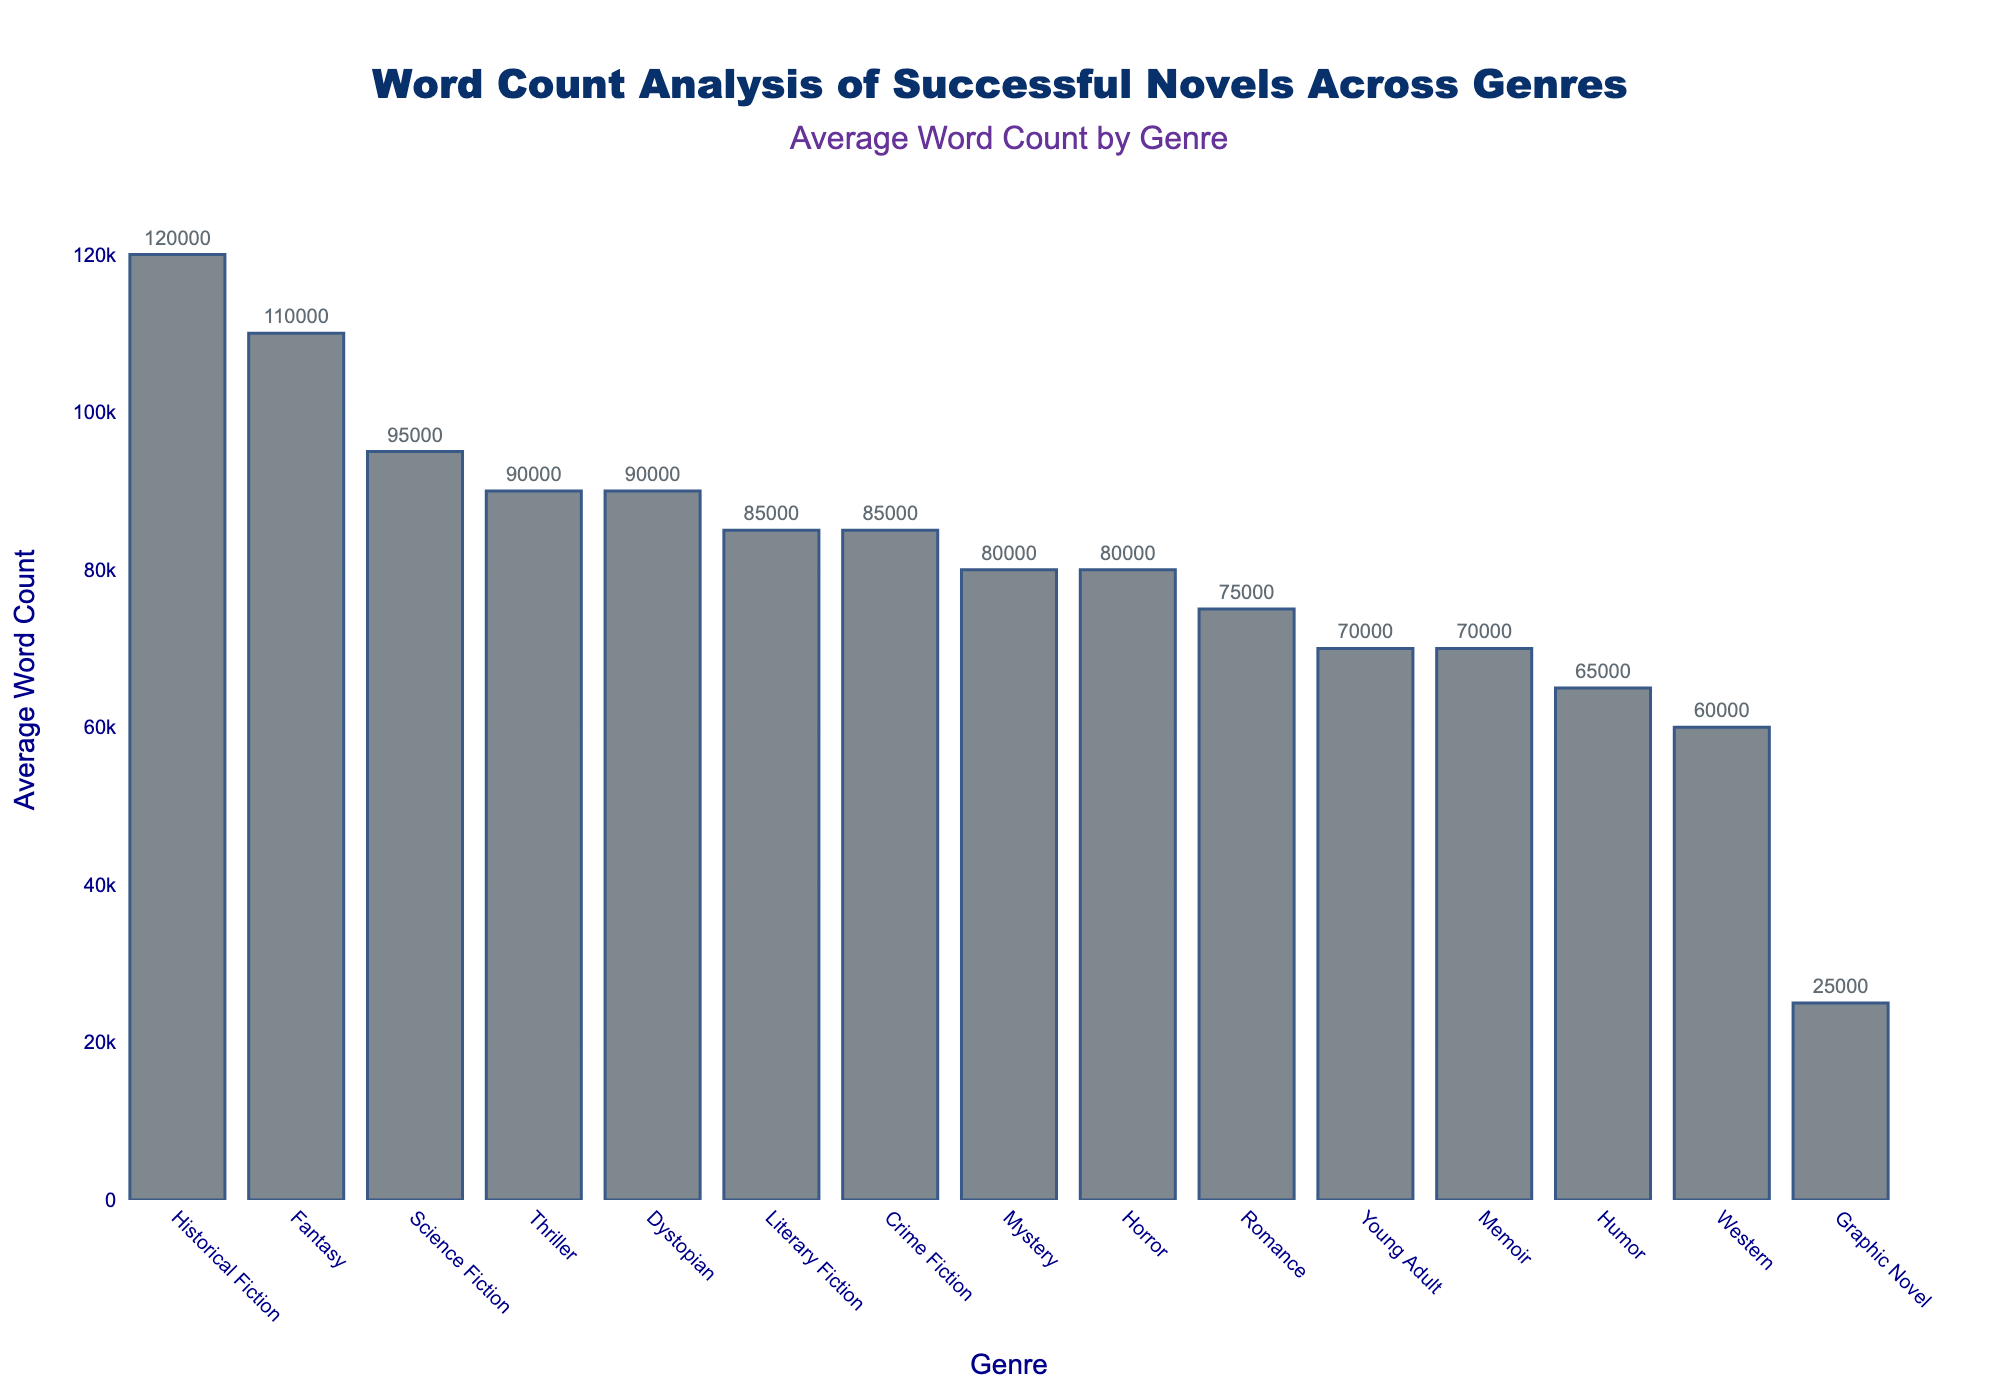Which genre has the highest average word count? By looking at the height of the bars, the highest bar corresponds to Historical Fiction.
Answer: Historical Fiction Which genre has the lowest average word count? The shortest bar corresponds to Graphic Novel.
Answer: Graphic Novel How does the average word count of Fantasy compare to Science Fiction? The bar for Fantasy is taller than the bar for Science Fiction, indicating that Fantasy has a higher average word count.
Answer: Fantasy is higher What is the difference in average word count between Historical Fiction and Romance? Historical Fiction has an average word count of 120,000, and Romance has 75,000. Subtracting these values gives 120,000 - 75,000.
Answer: 45,000 Is the average word count for Dystopian novels closer to Science Fiction or Thriller? The average word counts are: Dystopian (90,000), Science Fiction (95,000), and Thriller (90,000). Dystopian equals Thriller and is 5,000 closer to Science Fiction.
Answer: Closer to Thriller How many genres have an average word count greater than 85,000? Looking at the bars, Fantasy (110,000), Science Fiction (95,000), Historical Fiction (120,000), and Dystopian (90,000) all have word counts greater than 85,000.
Answer: 4 Do Memoirs or Westerns have a higher average word count? By comparing the heights of the bars, Memoirs (70,000) are taller than Westerns (60,000).
Answer: Memoirs What is the average word count across the genres of Crime Fiction and Literary Fiction? The average word counts are Crime Fiction (85,000) and Literary Fiction (85,000). The average is (85,000 + 85,000) / 2.
Answer: 85,000 Which genre has a closer average word count to Mystery: Horror or Romance? The average word counts are Mystery (80,000), Horror (80,000), and Romance (75,000). Because Horror has 80,000, the same as Mystery, it is closer than Romance.
Answer: Horror Is the difference between the highest and the lowest average word counts within the same order of magnitude? The highest average word count is 120,000 (Historical Fiction) and the lowest is 25,000 (Graphic Novel). The difference is 120,000 - 25,000 = 95,000, which is within the same order of magnitude (10^5).
Answer: Yes 